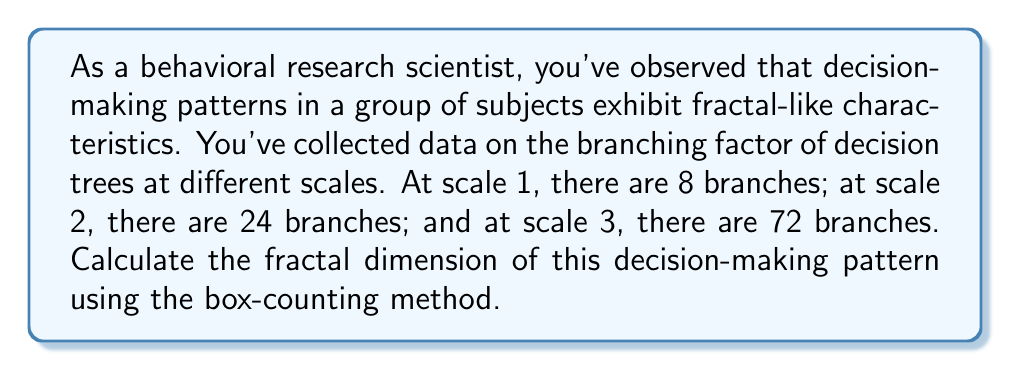Show me your answer to this math problem. To calculate the fractal dimension using the box-counting method, we'll follow these steps:

1) The box-counting dimension is defined as:

   $$D = \lim_{\epsilon \to 0} \frac{\log N(\epsilon)}{\log(1/\epsilon)}$$

   where $N(\epsilon)$ is the number of boxes of side length $\epsilon$ needed to cover the set.

2) In our case, we have three scales, so we'll use the slope of the log-log plot:

   $$D \approx \frac{\log(N_2/N_1)}{\log(\epsilon_1/\epsilon_2)}$$

   where $N_1$ and $N_2$ are the number of boxes at two different scales, and $\epsilon_1$ and $\epsilon_2$ are the corresponding box sizes.

3) Let's use scale 1 and scale 3 for our calculation:
   $N_1 = 8$, $N_3 = 72$
   $\epsilon_1 = 1$, $\epsilon_3 = 1/3$ (since we're going from scale 1 to 3)

4) Plugging into our formula:

   $$D \approx \frac{\log(72/8)}{\log(1/(1/3))} = \frac{\log(9)}{\log(3)}$$

5) Simplify:

   $$D = \frac{\log(3^2)}{\log(3)} = \frac{2\log(3)}{\log(3)} = 2$$

Therefore, the fractal dimension of this decision-making pattern is approximately 2.
Answer: The fractal dimension of the decision-making pattern is 2. 